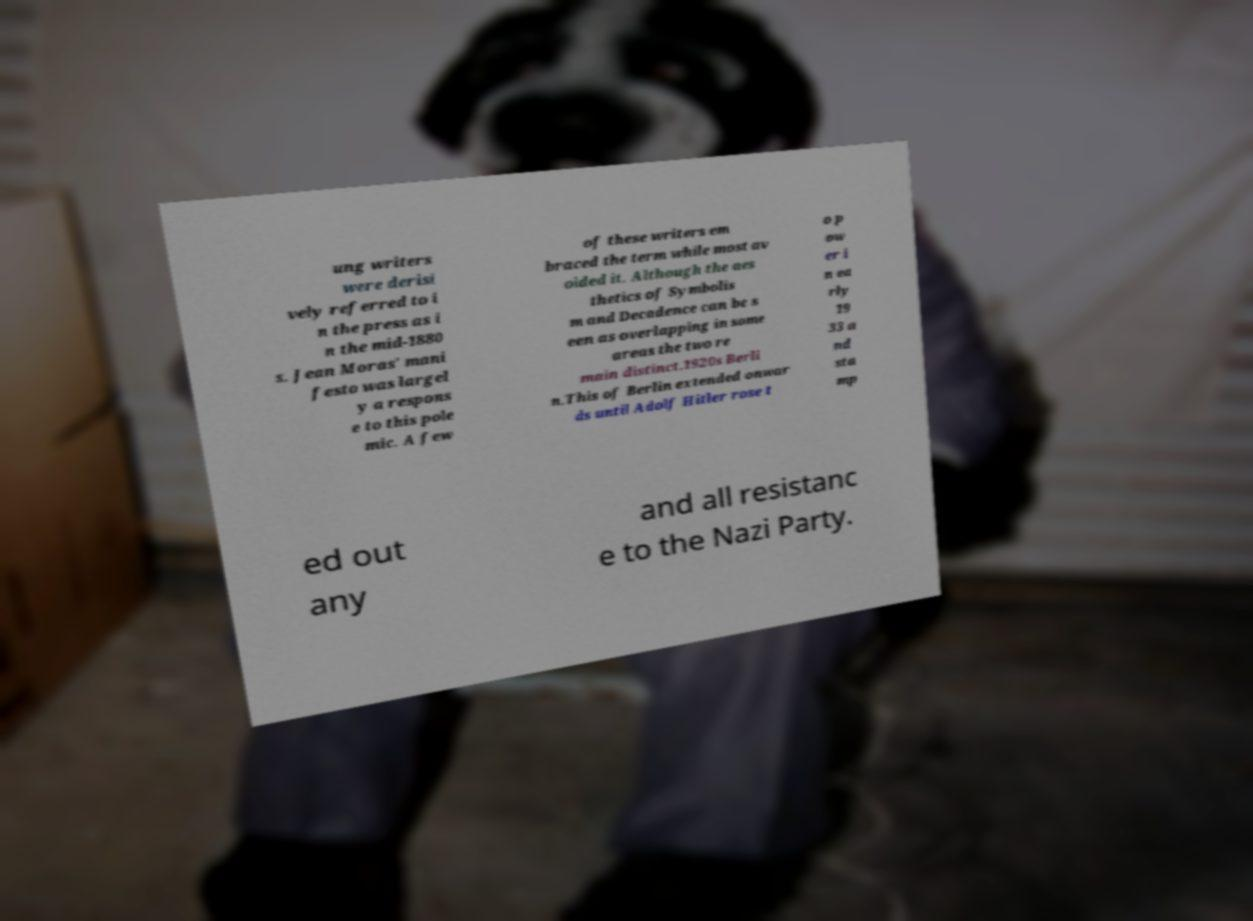Can you read and provide the text displayed in the image?This photo seems to have some interesting text. Can you extract and type it out for me? ung writers were derisi vely referred to i n the press as i n the mid-1880 s. Jean Moras' mani festo was largel y a respons e to this pole mic. A few of these writers em braced the term while most av oided it. Although the aes thetics of Symbolis m and Decadence can be s een as overlapping in some areas the two re main distinct.1920s Berli n.This of Berlin extended onwar ds until Adolf Hitler rose t o p ow er i n ea rly 19 33 a nd sta mp ed out any and all resistanc e to the Nazi Party. 